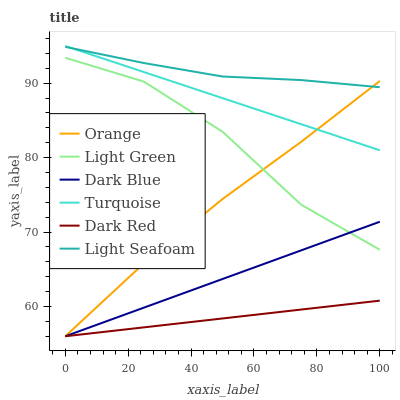Does Dark Red have the minimum area under the curve?
Answer yes or no. Yes. Does Light Seafoam have the maximum area under the curve?
Answer yes or no. Yes. Does Dark Blue have the minimum area under the curve?
Answer yes or no. No. Does Dark Blue have the maximum area under the curve?
Answer yes or no. No. Is Dark Red the smoothest?
Answer yes or no. Yes. Is Light Green the roughest?
Answer yes or no. Yes. Is Dark Blue the smoothest?
Answer yes or no. No. Is Dark Blue the roughest?
Answer yes or no. No. Does Light Green have the lowest value?
Answer yes or no. No. Does Turquoise have the highest value?
Answer yes or no. Yes. Does Dark Blue have the highest value?
Answer yes or no. No. Is Dark Red less than Turquoise?
Answer yes or no. Yes. Is Light Seafoam greater than Dark Red?
Answer yes or no. Yes. Does Orange intersect Dark Blue?
Answer yes or no. Yes. Is Orange less than Dark Blue?
Answer yes or no. No. Is Orange greater than Dark Blue?
Answer yes or no. No. Does Dark Red intersect Turquoise?
Answer yes or no. No. 